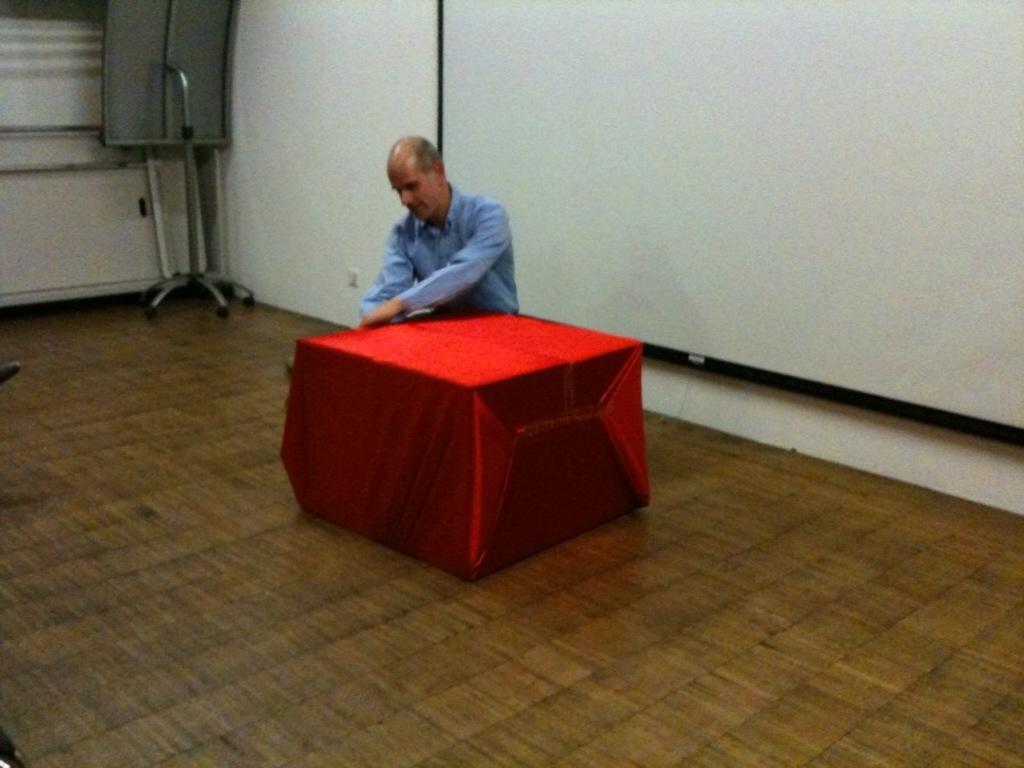What is the person in the image doing? The person is sitting on the floor. What else can be seen on the floor in the image? There is an object on the floor. What can be seen in the background of the image? There is a wall in the background of the image. What color are the trousers of the person walking in the image? There is no person walking in the image, and the person sitting on the floor is not wearing trousers. 